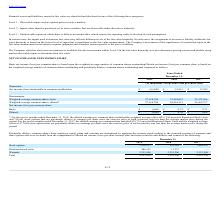From Finjan Holding's financial document, What is the respective number of unvested Restricted Stock Units and stock options included in the diluted earnings per common share for the twelve months ended December 31, 2018? The document shows two values: 215,196 and 716,661. From the document: "mon share included the weighted average effect of 215,196 unvested Restricted Stock Units and 716,661 stock options that are potentially dilutive to e..." Also, What is the respective number of unvested Restricted Stock Units and stock options included in the diluted earnings per common share for the twelve months ended December 31, 2017? The document shows two values: 438,712 and 477,048. From the document: "7, the diluted earnings per common share included 438,712 unvested Restricted Stock Units and the weighted average effect of 477,048 stock options tha..." Also, What is the respective number of weighted-average common shares, basic in 2019 and 2018 respectively? The document shows two values: 27,618,284 and 27,484,655. From the document: "enominator: Weighted-average common shares, basic 27,618,284 27,484,655 25,353,966 Weighted-average common shares, basic 27,618,284 27,484,655 25,353,..." Also, can you calculate: What is the number of unvested Restricted Stock Units as a percentage of the total Weighted-average common shares, diluted in 2018? Based on the calculation: 215,196/28,416,512 , the result is 0.76 (percentage). This is based on the information: "ighted-average common shares, diluted* 27,618,284 28,416,512 26,269,727 mon share included the weighted average effect of 215,196 unvested Restricted Stock Units and 716,661 stock options that are pot..." The key data points involved are: 215,196, 28,416,512. Also, can you calculate: What is the number of unvested Restricted Stock Units as a percentage of the total Weighted-average common shares, diluted in 2017? Based on the calculation: 438,712 /26,269,727 , the result is 1.67 (percentage). This is based on the information: "age common shares, diluted* 27,618,284 28,416,512 26,269,727 7, the diluted earnings per common share included 438,712 unvested Restricted Stock Units and the weighted average effect of 477,048 stock ..." The key data points involved are: 26,269,727, 438,712. Also, can you calculate: What is the number of potentially dilutive stock options as a percentage of the total Weighted-average common shares, diluted in 2018? Based on the calculation: 716,661/28,416,512 , the result is 2.52 (percentage). This is based on the information: "ighted-average common shares, diluted* 27,618,284 28,416,512 26,269,727 ct of 215,196 unvested Restricted Stock Units and 716,661 stock options that are potentially dilutive to earnings per share sinc..." The key data points involved are: 28,416,512, 716,661. 